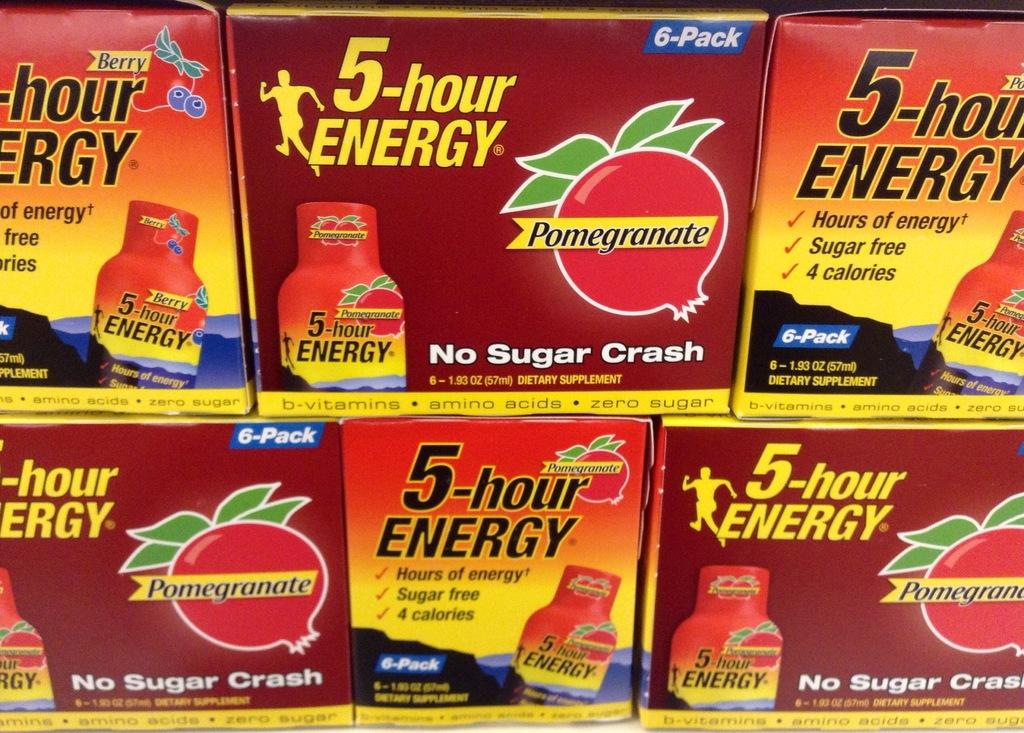<image>
Share a concise interpretation of the image provided. Six boxes of 5 hour Energy with three of them haing Pomegranate flavoring to it and No Sugar Crash written on the box. 